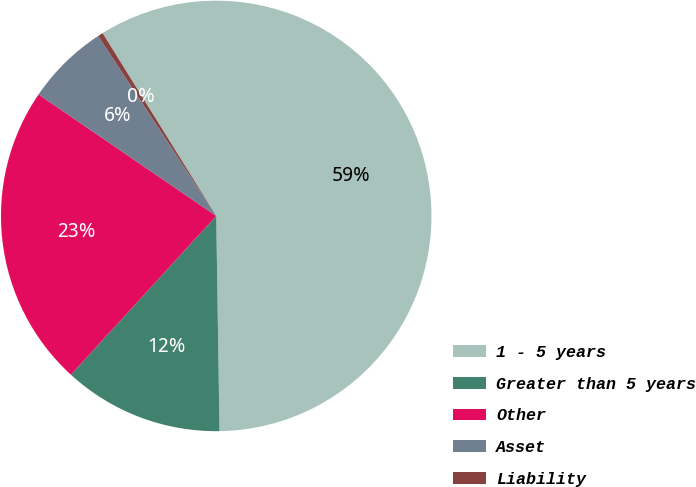Convert chart to OTSL. <chart><loc_0><loc_0><loc_500><loc_500><pie_chart><fcel>1 - 5 years<fcel>Greater than 5 years<fcel>Other<fcel>Asset<fcel>Liability<nl><fcel>58.61%<fcel>12.04%<fcel>22.75%<fcel>6.21%<fcel>0.39%<nl></chart> 